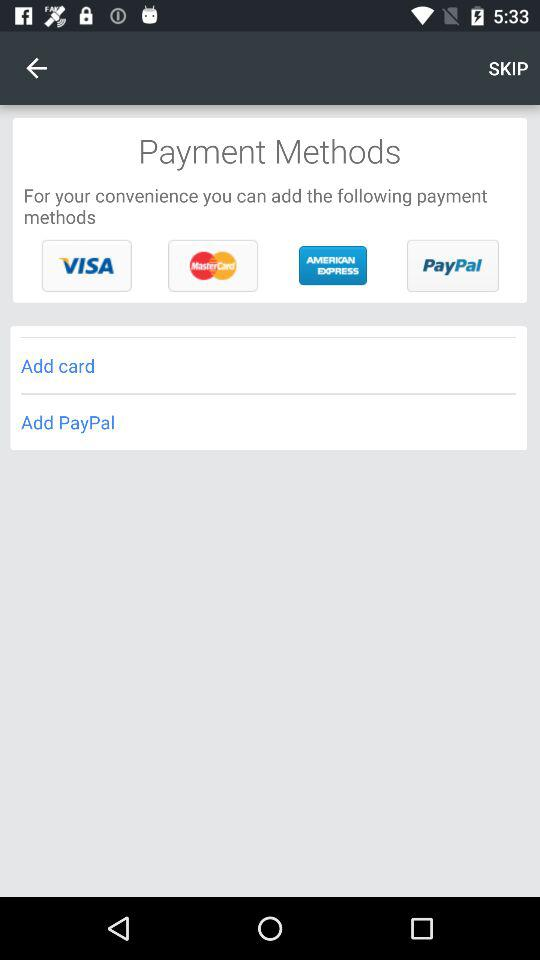What payment method is used in the add option? The payment methods are "VISA", "MasterCard", "AMERICAN EXPRESS", "PayPal", "Add card" and "Add PayPal". 